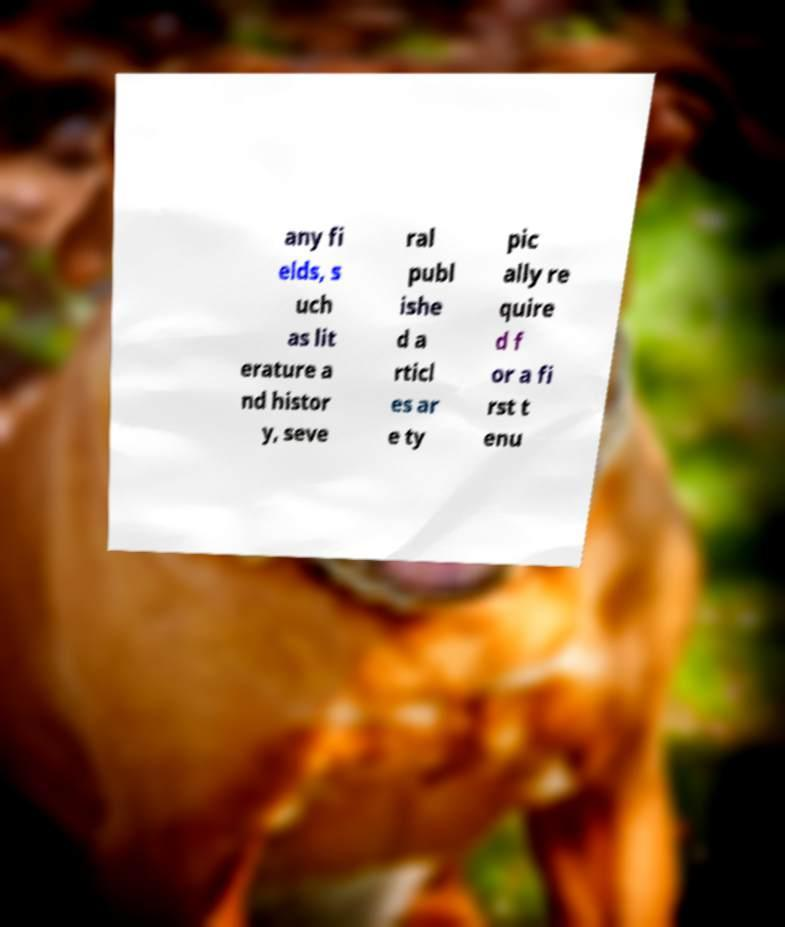Can you accurately transcribe the text from the provided image for me? any fi elds, s uch as lit erature a nd histor y, seve ral publ ishe d a rticl es ar e ty pic ally re quire d f or a fi rst t enu 